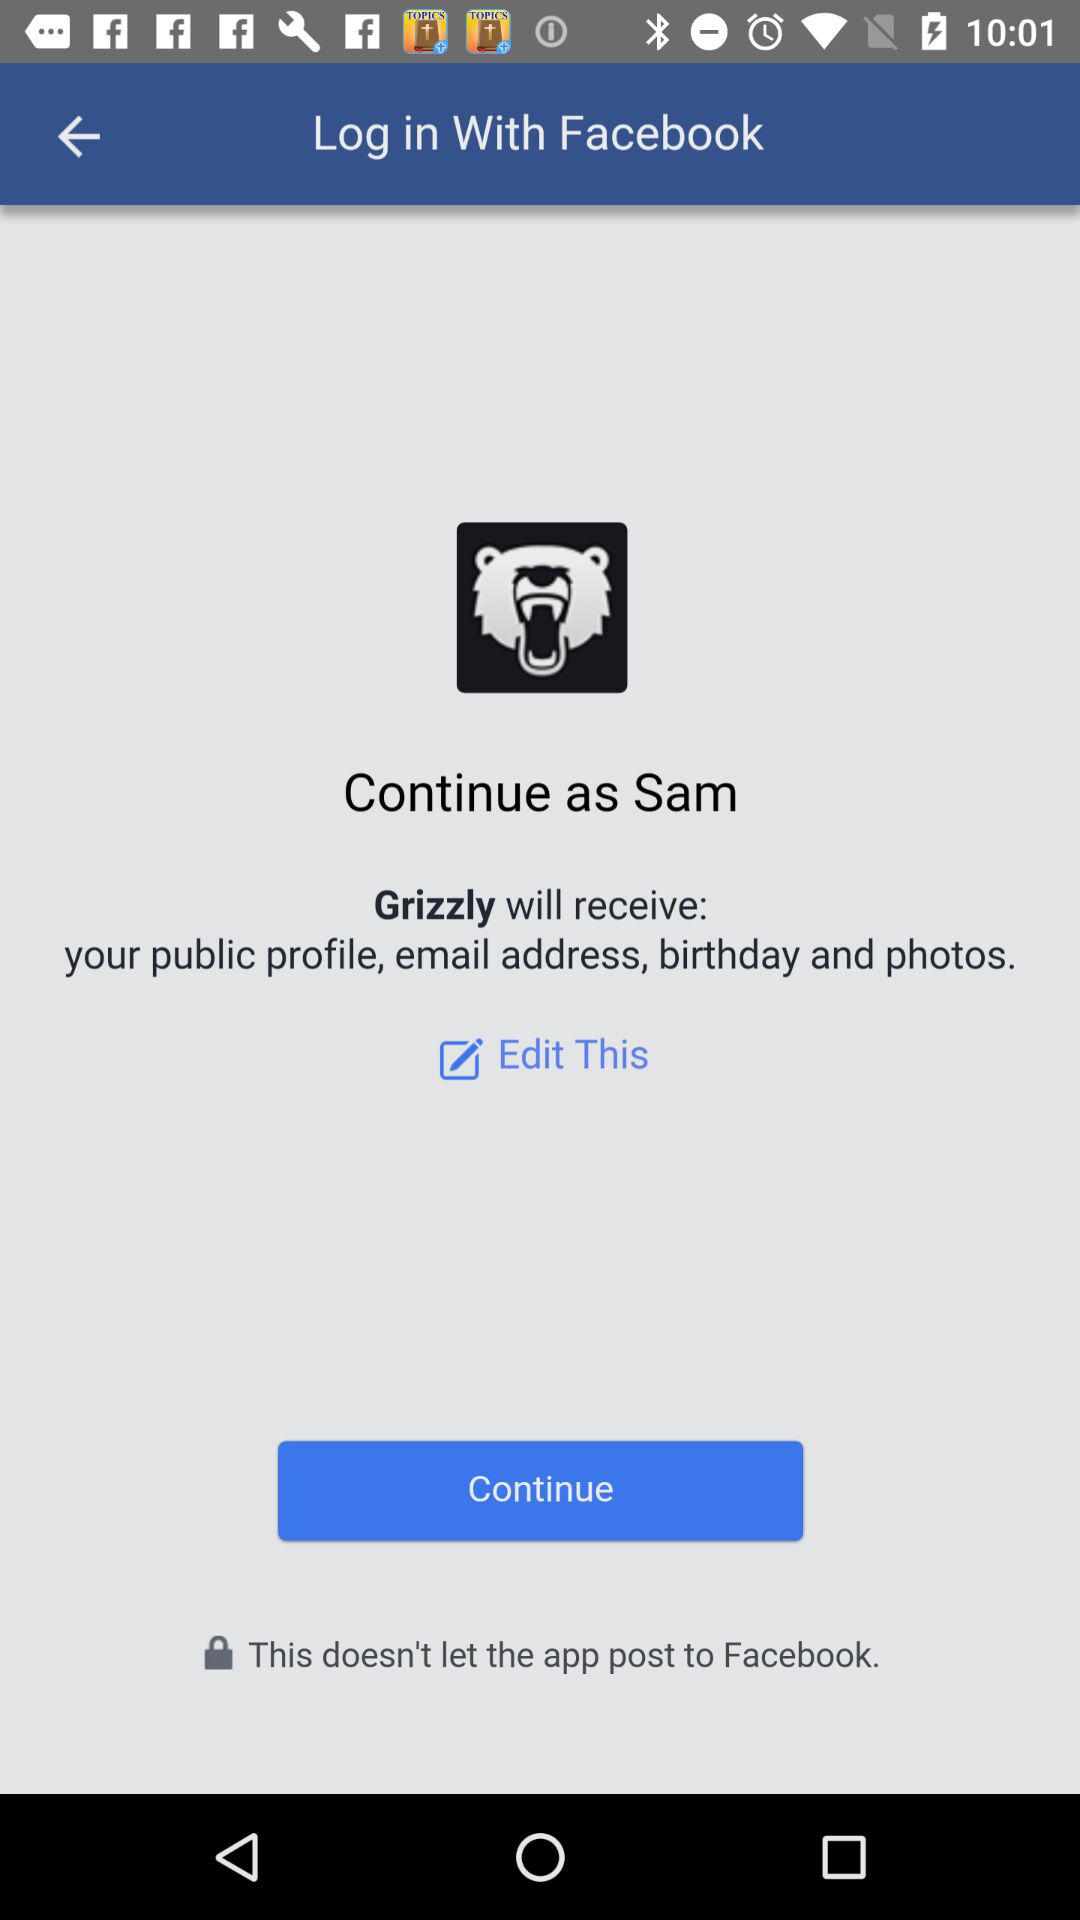What applications can be used to log in to the profile? The application that can be used to log in to the profile is "Facebook". 